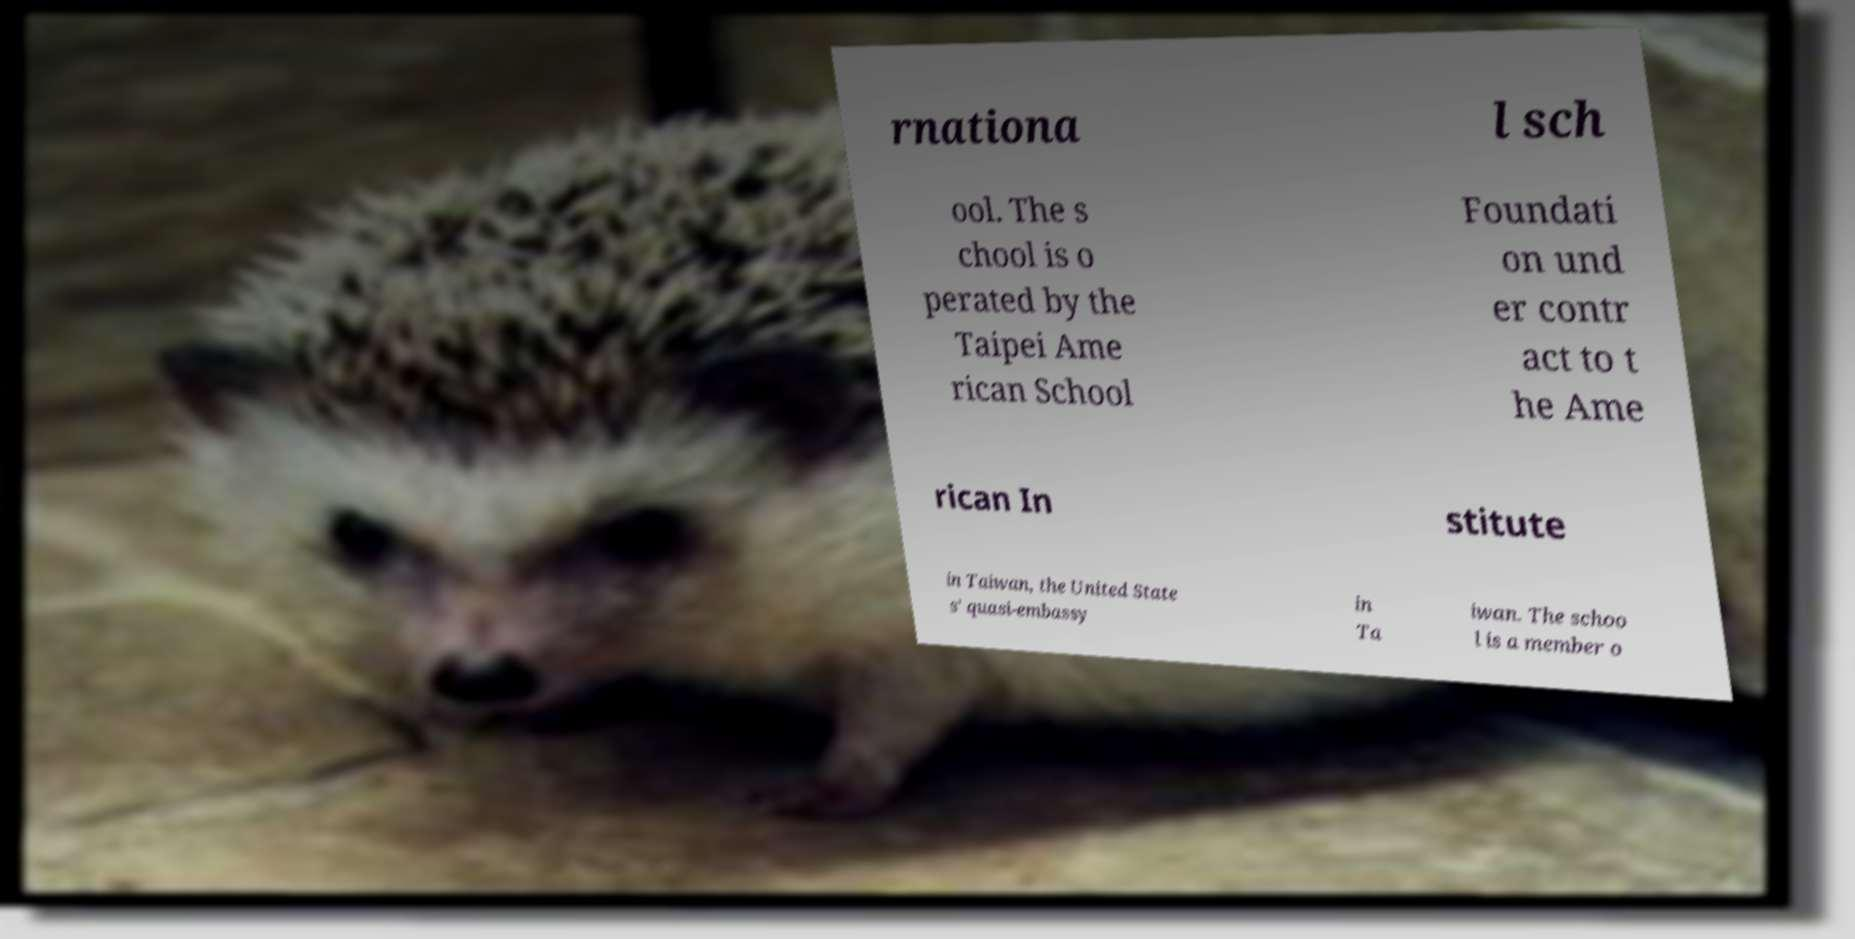Can you read and provide the text displayed in the image?This photo seems to have some interesting text. Can you extract and type it out for me? rnationa l sch ool. The s chool is o perated by the Taipei Ame rican School Foundati on und er contr act to t he Ame rican In stitute in Taiwan, the United State s' quasi-embassy in Ta iwan. The schoo l is a member o 